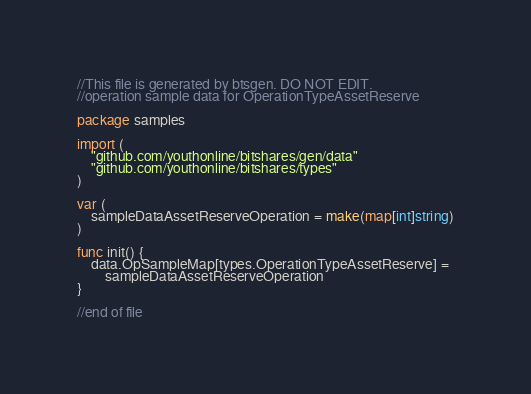Convert code to text. <code><loc_0><loc_0><loc_500><loc_500><_Go_>//This file is generated by btsgen. DO NOT EDIT.
//operation sample data for OperationTypeAssetReserve

package samples

import (
	"github.com/youthonline/bitshares/gen/data"
	"github.com/youthonline/bitshares/types"
)

var (
	sampleDataAssetReserveOperation = make(map[int]string)
)

func init() {
	data.OpSampleMap[types.OperationTypeAssetReserve] =
		sampleDataAssetReserveOperation
}

//end of file
</code> 